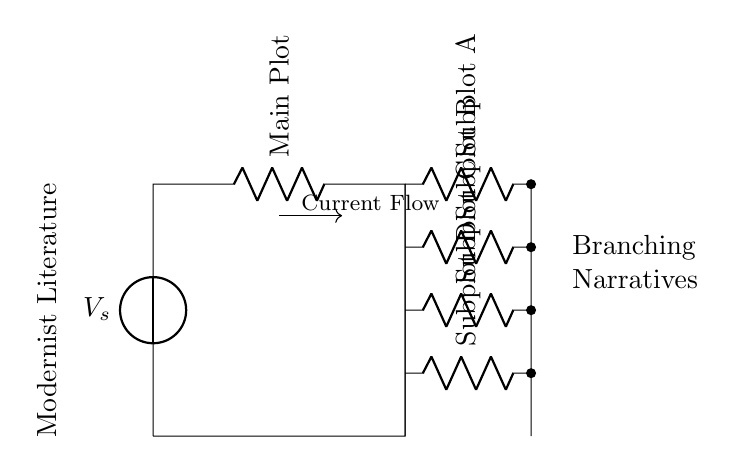What is the voltage source labeled in the circuit? The voltage source is labeled as "V_s," which indicates the source providing voltage to the circuit.
Answer: V_s What components are present in subplot A? Subplot A contains a resistor, as indicated by the symbol in the diagram and the accompanying label.
Answer: Resistor How many subplots are shown in the circuit? There are a total of four subplots labeled A, B, C, and D, indicating the various branches from the main plot.
Answer: Four What does the arrow represent in this diagram? The arrow indicates the direction of current flow, showing how the current moves through the circuit from the source to the branches.
Answer: Current Flow What is the main plot of the circuit labeled as? The main plot is labeled as "Main Plot," which signifies the primary pathway through which current flows before branching into subplots.
Answer: Main Plot Which subplot represents the topmost branch? The topmost branch is represented by subplot A, as it is the highest in the diagram layout.
Answer: Subplot A How does the structure of this circuit relate to modernist literature? The branching of the circuit represents the nonlinear narratives found in modernist literature, where multiple paths or stories emerge simultaneously.
Answer: Branching Narratives 